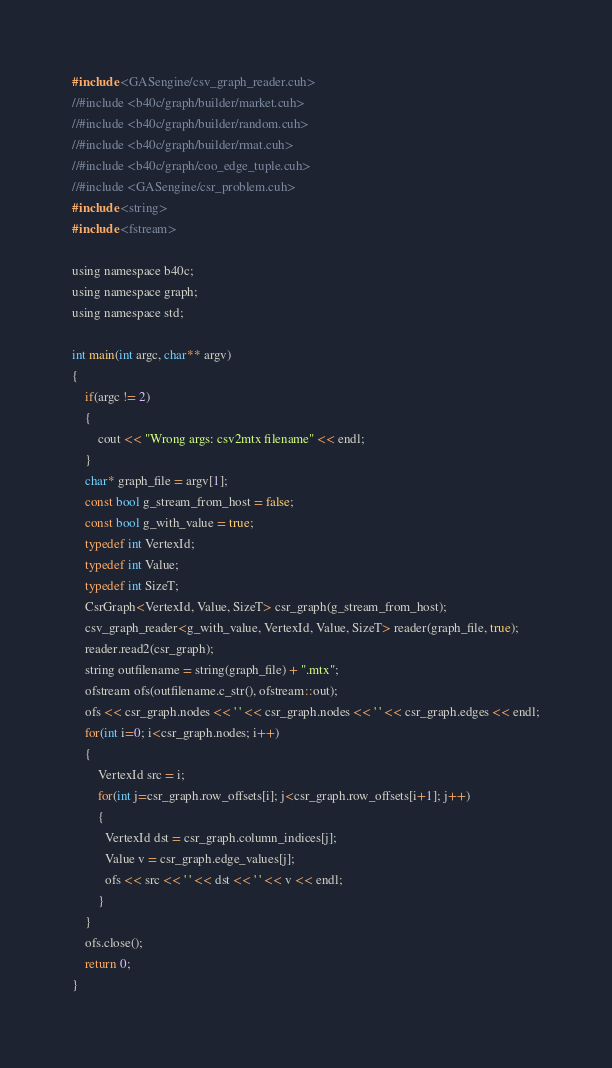<code> <loc_0><loc_0><loc_500><loc_500><_Cuda_>#include <GASengine/csv_graph_reader.cuh>
//#include <b40c/graph/builder/market.cuh>
//#include <b40c/graph/builder/random.cuh>
//#include <b40c/graph/builder/rmat.cuh>
//#include <b40c/graph/coo_edge_tuple.cuh>
//#include <GASengine/csr_problem.cuh>
#include <string>
#include <fstream>

using namespace b40c;
using namespace graph;
using namespace std;

int main(int argc, char** argv)
{
	if(argc != 2)
	{
		cout << "Wrong args: csv2mtx filename" << endl;
	}
	char* graph_file = argv[1];
	const bool g_stream_from_host = false;
	const bool g_with_value = true;
	typedef int VertexId;
	typedef int Value;
	typedef int SizeT;
	CsrGraph<VertexId, Value, SizeT> csr_graph(g_stream_from_host);
	csv_graph_reader<g_with_value, VertexId, Value, SizeT> reader(graph_file, true);
	reader.read2(csr_graph);
	string outfilename = string(graph_file) + ".mtx";
	ofstream ofs(outfilename.c_str(), ofstream::out);
	ofs << csr_graph.nodes << ' ' << csr_graph.nodes << ' ' << csr_graph.edges << endl;
	for(int i=0; i<csr_graph.nodes; i++)
	{
		VertexId src = i;
		for(int j=csr_graph.row_offsets[i]; j<csr_graph.row_offsets[i+1]; j++)
		{
          VertexId dst = csr_graph.column_indices[j];
          Value v = csr_graph.edge_values[j];
          ofs << src << ' ' << dst << ' ' << v << endl;
		}
	}
	ofs.close();
	return 0;
}
</code> 